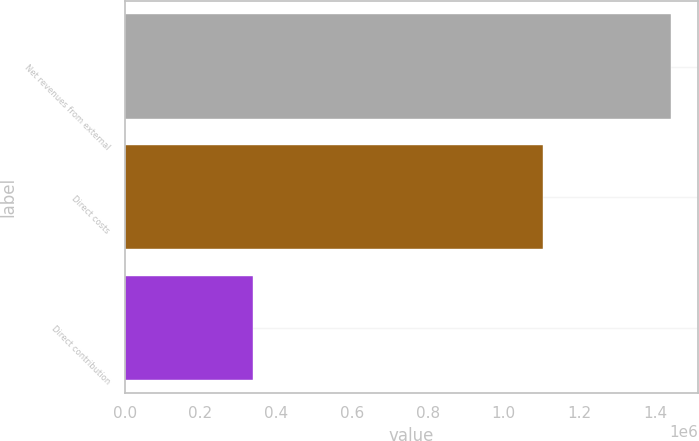Convert chart to OTSL. <chart><loc_0><loc_0><loc_500><loc_500><bar_chart><fcel>Net revenues from external<fcel>Direct costs<fcel>Direct contribution<nl><fcel>1.44053e+06<fcel>1.10292e+06<fcel>337611<nl></chart> 